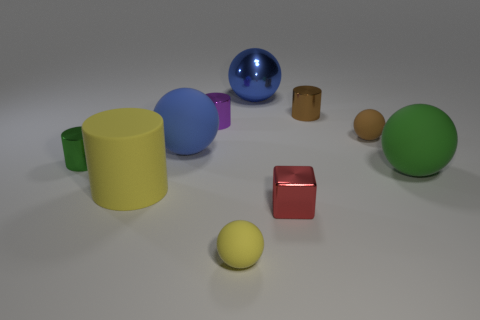There is a rubber sphere that is the same color as the metal ball; what is its size?
Ensure brevity in your answer.  Large. What shape is the big matte object that is the same color as the metal ball?
Keep it short and to the point. Sphere. What size is the brown object to the left of the small brown rubber object?
Ensure brevity in your answer.  Small. How many large objects are either brown metallic things or purple metallic cylinders?
Your answer should be compact. 0. There is another large matte object that is the same shape as the blue rubber object; what is its color?
Keep it short and to the point. Green. Do the brown rubber ball and the metallic block have the same size?
Your answer should be very brief. Yes. What number of things are big red shiny cylinders or yellow things that are in front of the small cube?
Keep it short and to the point. 1. There is a tiny rubber sphere behind the small matte object that is left of the red block; what color is it?
Provide a succinct answer. Brown. There is a tiny rubber thing on the left side of the large metal sphere; does it have the same color as the large matte cylinder?
Offer a terse response. Yes. There is a blue object left of the metallic ball; what is it made of?
Make the answer very short. Rubber. 